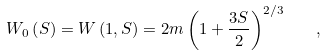<formula> <loc_0><loc_0><loc_500><loc_500>W _ { 0 } \left ( S \right ) = W \left ( 1 , S \right ) = 2 m \left ( 1 + \frac { 3 S } { 2 } \right ) ^ { 2 / 3 } \quad ,</formula> 